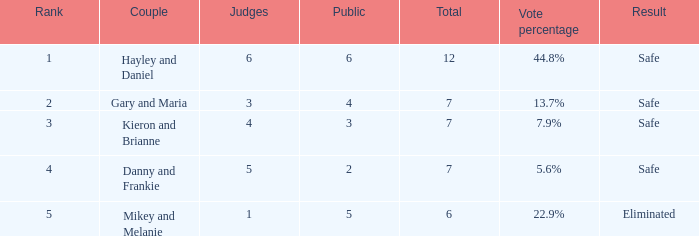How many individuals are present for the couple that got removed? 5.0. 